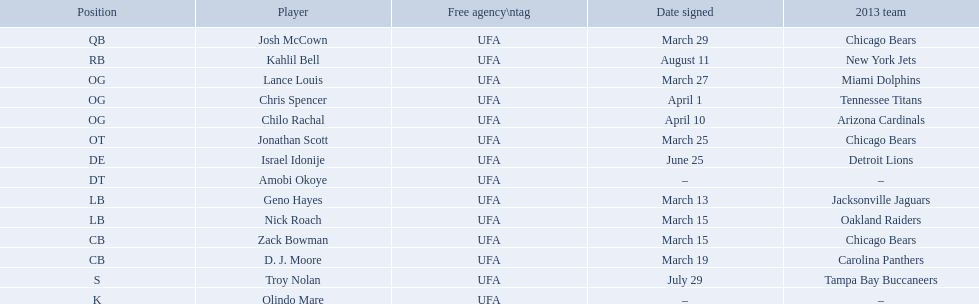Who are all the players on the 2013 chicago bears season team? Josh McCown, Kahlil Bell, Lance Louis, Chris Spencer, Chilo Rachal, Jonathan Scott, Israel Idonije, Amobi Okoye, Geno Hayes, Nick Roach, Zack Bowman, D. J. Moore, Troy Nolan, Olindo Mare. What day was nick roach signed? March 15. What other day matches this? March 15. Who was signed on the day? Zack Bowman. Who are all the members? Josh McCown, Kahlil Bell, Lance Louis, Chris Spencer, Chilo Rachal, Jonathan Scott, Israel Idonije, Amobi Okoye, Geno Hayes, Nick Roach, Zack Bowman, D. J. Moore, Troy Nolan, Olindo Mare. When were they recruited? March 29, August 11, March 27, April 1, April 10, March 25, June 25, –, March 13, March 15, March 15, March 19, July 29, –. Besides nick roach, who else was signed on march 15? Zack Bowman. What are all the signed dates? March 29, August 11, March 27, April 1, April 10, March 25, June 25, March 13, March 15, March 15, March 19, July 29. Which of these are repetitions? March 15, March 15. Who has the identical one as nick roach? Zack Bowman. What are all the signed dates? March 29, August 11, March 27, April 1, April 10, March 25, June 25, March 13, March 15, March 15, March 19, July 29. Which among them are double entries? March 15, March 15. Who holds the same one as nick roach? Zack Bowman. What are the complete list of signed dates? March 29, August 11, March 27, April 1, April 10, March 25, June 25, March 13, March 15, March 15, March 19, July 29. Which among them are repeated? March 15, March 15. Who shares the same signed date with nick roach? Zack Bowman. Who were the members of the chicago bears during the 2013 season? Josh McCown, Kahlil Bell, Lance Louis, Chris Spencer, Chilo Rachal, Jonathan Scott, Israel Idonije, Amobi Okoye, Geno Hayes, Nick Roach, Zack Bowman, D. J. Moore, Troy Nolan, Olindo Mare. On which date was nick roach signed? March 15. Can you provide another date with the same significance? March 15. Who else was signed on that day? Zack Bowman. Who constituted the 2013 chicago bears team? Josh McCown, Kahlil Bell, Lance Louis, Chris Spencer, Chilo Rachal, Jonathan Scott, Israel Idonije, Amobi Okoye, Geno Hayes, Nick Roach, Zack Bowman, D. J. Moore, Troy Nolan, Olindo Mare. What was the signing date for nick roach? March 15. Is there another date of equal significance? March 15. Who was the player signed on that day? Zack Bowman. 